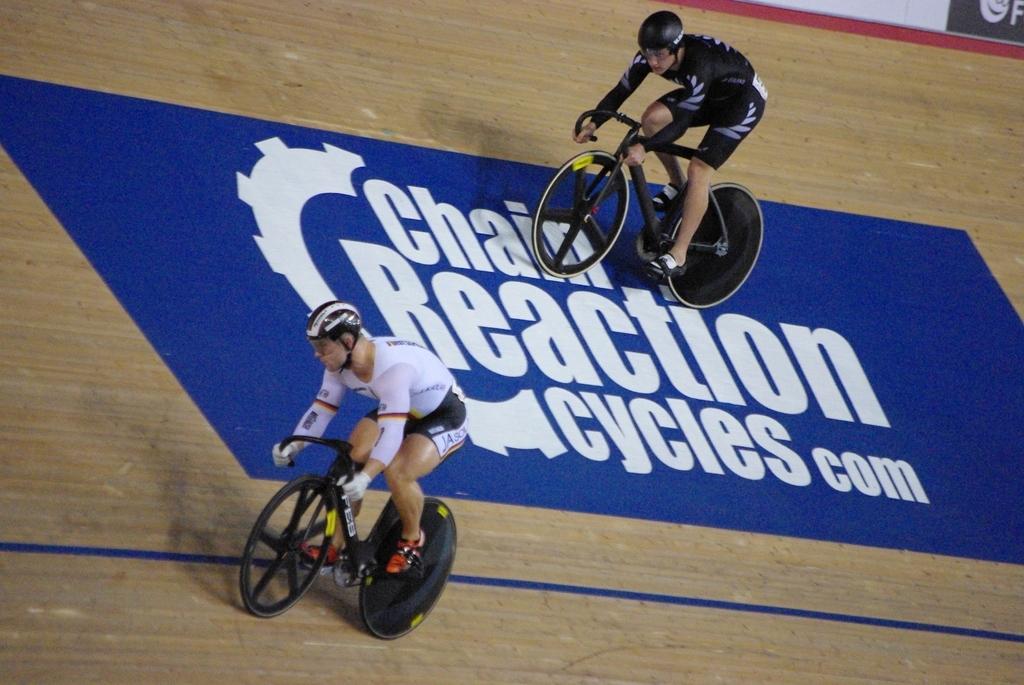<image>
Offer a succinct explanation of the picture presented. Two cyclists race around a track that is sponsored by Chain Reaction Cycles. 